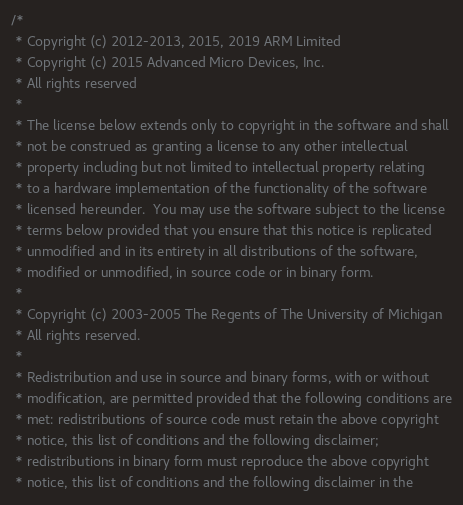<code> <loc_0><loc_0><loc_500><loc_500><_C++_>/*
 * Copyright (c) 2012-2013, 2015, 2019 ARM Limited
 * Copyright (c) 2015 Advanced Micro Devices, Inc.
 * All rights reserved
 *
 * The license below extends only to copyright in the software and shall
 * not be construed as granting a license to any other intellectual
 * property including but not limited to intellectual property relating
 * to a hardware implementation of the functionality of the software
 * licensed hereunder.  You may use the software subject to the license
 * terms below provided that you ensure that this notice is replicated
 * unmodified and in its entirety in all distributions of the software,
 * modified or unmodified, in source code or in binary form.
 *
 * Copyright (c) 2003-2005 The Regents of The University of Michigan
 * All rights reserved.
 *
 * Redistribution and use in source and binary forms, with or without
 * modification, are permitted provided that the following conditions are
 * met: redistributions of source code must retain the above copyright
 * notice, this list of conditions and the following disclaimer;
 * redistributions in binary form must reproduce the above copyright
 * notice, this list of conditions and the following disclaimer in the</code> 